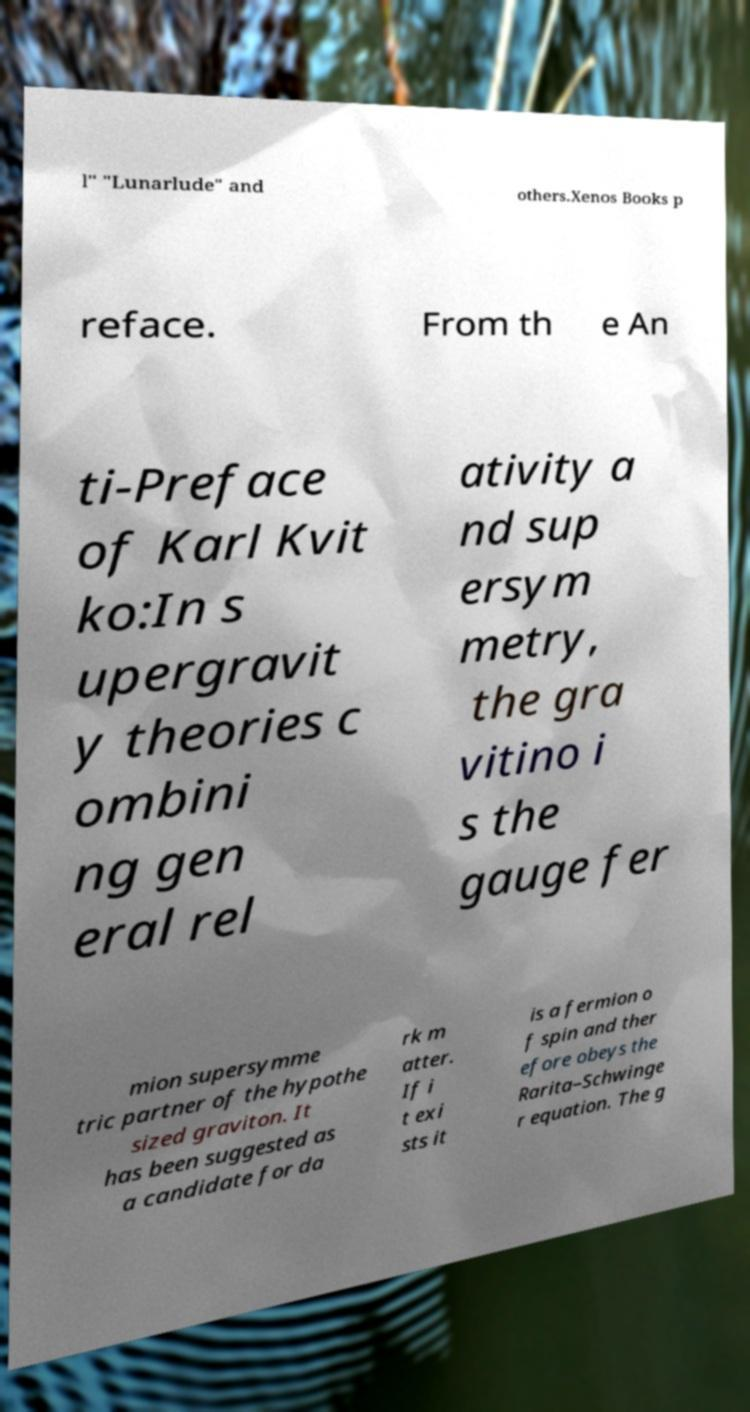I need the written content from this picture converted into text. Can you do that? l" "Lunarlude" and others.Xenos Books p reface. From th e An ti-Preface of Karl Kvit ko:In s upergravit y theories c ombini ng gen eral rel ativity a nd sup ersym metry, the gra vitino i s the gauge fer mion supersymme tric partner of the hypothe sized graviton. It has been suggested as a candidate for da rk m atter. If i t exi sts it is a fermion o f spin and ther efore obeys the Rarita–Schwinge r equation. The g 